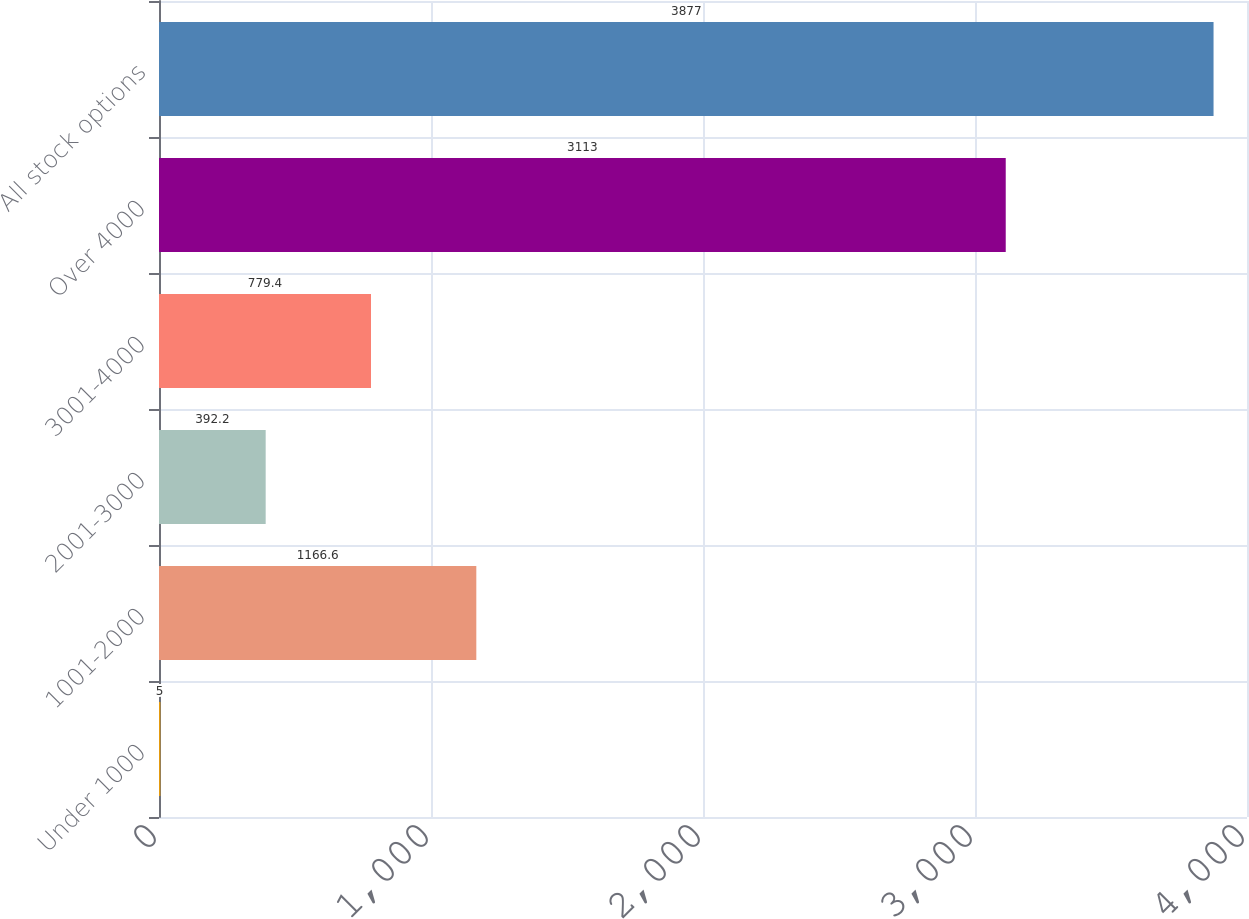<chart> <loc_0><loc_0><loc_500><loc_500><bar_chart><fcel>Under 1000<fcel>1001-2000<fcel>2001-3000<fcel>3001-4000<fcel>Over 4000<fcel>All stock options<nl><fcel>5<fcel>1166.6<fcel>392.2<fcel>779.4<fcel>3113<fcel>3877<nl></chart> 